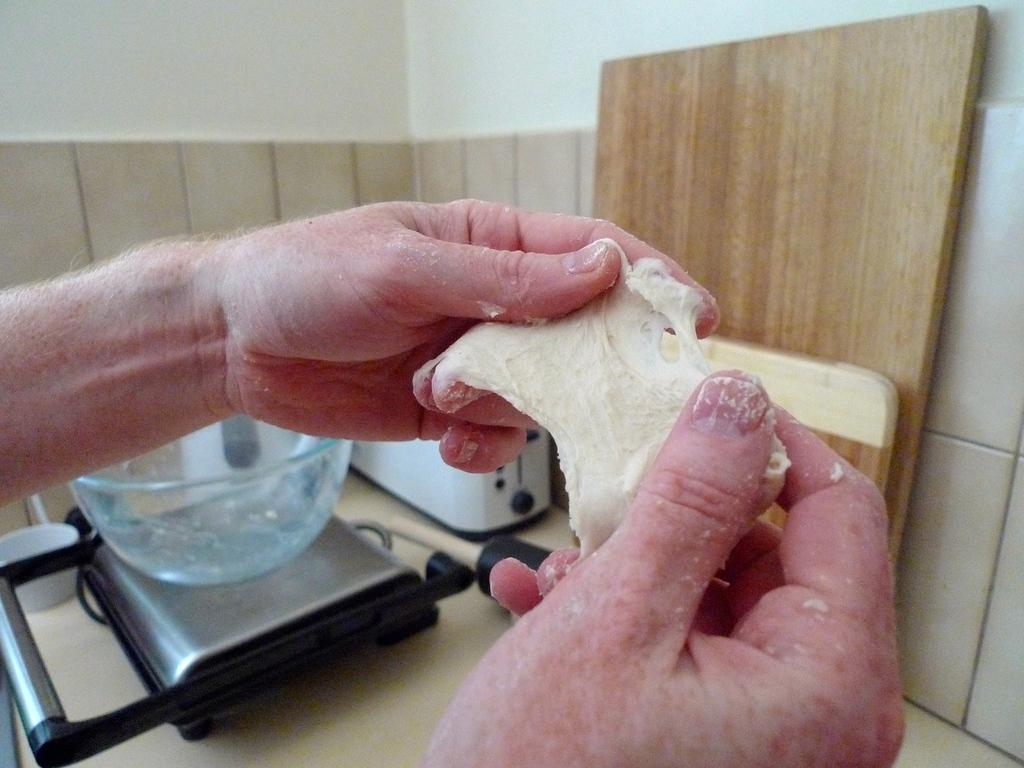What part of the person's body can be seen in the image? The person's hands are visible in the image. What is the person holding in their hands? The person is holding a white object. What can be seen in the background of the image? There is a bowl, machines, and brown boards on a cream surface in the background of the image. What type of structure is visible in the image? There is a wall visible in the image. What type of meal is being prepared on the brown boards in the image? There is no meal preparation visible in the image; the brown boards are simply part of the background. Can you see any fangs in the image? There are no fangs present in the image. 